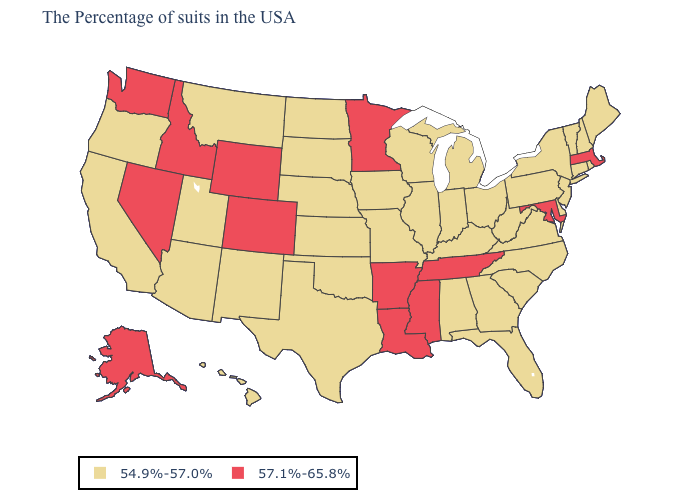What is the highest value in states that border Kansas?
Quick response, please. 57.1%-65.8%. What is the highest value in the USA?
Keep it brief. 57.1%-65.8%. What is the value of Illinois?
Short answer required. 54.9%-57.0%. What is the value of Arizona?
Quick response, please. 54.9%-57.0%. Does Oklahoma have a higher value than Ohio?
Quick response, please. No. What is the value of North Dakota?
Answer briefly. 54.9%-57.0%. What is the lowest value in states that border Ohio?
Be succinct. 54.9%-57.0%. Among the states that border Colorado , which have the highest value?
Be succinct. Wyoming. How many symbols are there in the legend?
Be succinct. 2. Name the states that have a value in the range 54.9%-57.0%?
Be succinct. Maine, Rhode Island, New Hampshire, Vermont, Connecticut, New York, New Jersey, Delaware, Pennsylvania, Virginia, North Carolina, South Carolina, West Virginia, Ohio, Florida, Georgia, Michigan, Kentucky, Indiana, Alabama, Wisconsin, Illinois, Missouri, Iowa, Kansas, Nebraska, Oklahoma, Texas, South Dakota, North Dakota, New Mexico, Utah, Montana, Arizona, California, Oregon, Hawaii. Does California have the highest value in the West?
Write a very short answer. No. Name the states that have a value in the range 54.9%-57.0%?
Concise answer only. Maine, Rhode Island, New Hampshire, Vermont, Connecticut, New York, New Jersey, Delaware, Pennsylvania, Virginia, North Carolina, South Carolina, West Virginia, Ohio, Florida, Georgia, Michigan, Kentucky, Indiana, Alabama, Wisconsin, Illinois, Missouri, Iowa, Kansas, Nebraska, Oklahoma, Texas, South Dakota, North Dakota, New Mexico, Utah, Montana, Arizona, California, Oregon, Hawaii. What is the value of New Jersey?
Answer briefly. 54.9%-57.0%. Which states have the lowest value in the USA?
Be succinct. Maine, Rhode Island, New Hampshire, Vermont, Connecticut, New York, New Jersey, Delaware, Pennsylvania, Virginia, North Carolina, South Carolina, West Virginia, Ohio, Florida, Georgia, Michigan, Kentucky, Indiana, Alabama, Wisconsin, Illinois, Missouri, Iowa, Kansas, Nebraska, Oklahoma, Texas, South Dakota, North Dakota, New Mexico, Utah, Montana, Arizona, California, Oregon, Hawaii. Which states have the lowest value in the West?
Be succinct. New Mexico, Utah, Montana, Arizona, California, Oregon, Hawaii. 